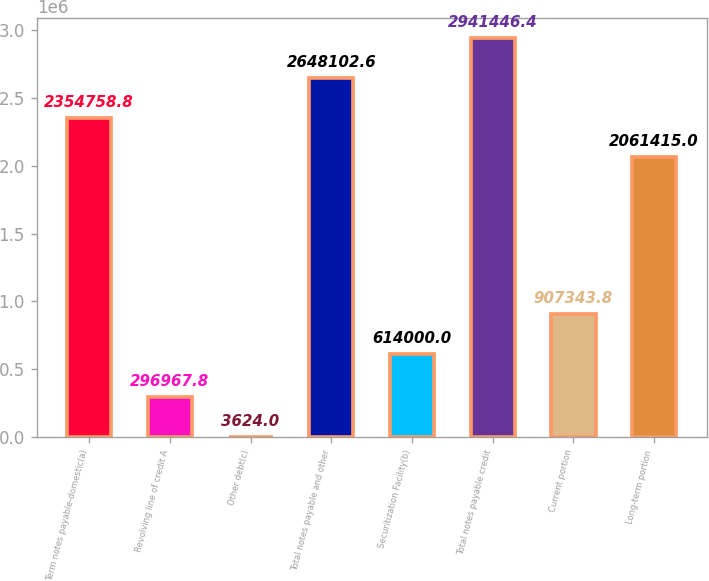Convert chart. <chart><loc_0><loc_0><loc_500><loc_500><bar_chart><fcel>Term notes payable-domestic(a)<fcel>Revolving line of credit A<fcel>Other debt(c)<fcel>Total notes payable and other<fcel>Securitization Facility(b)<fcel>Total notes payable credit<fcel>Current portion<fcel>Long-term portion<nl><fcel>2.35476e+06<fcel>296968<fcel>3624<fcel>2.6481e+06<fcel>614000<fcel>2.94145e+06<fcel>907344<fcel>2.06142e+06<nl></chart> 